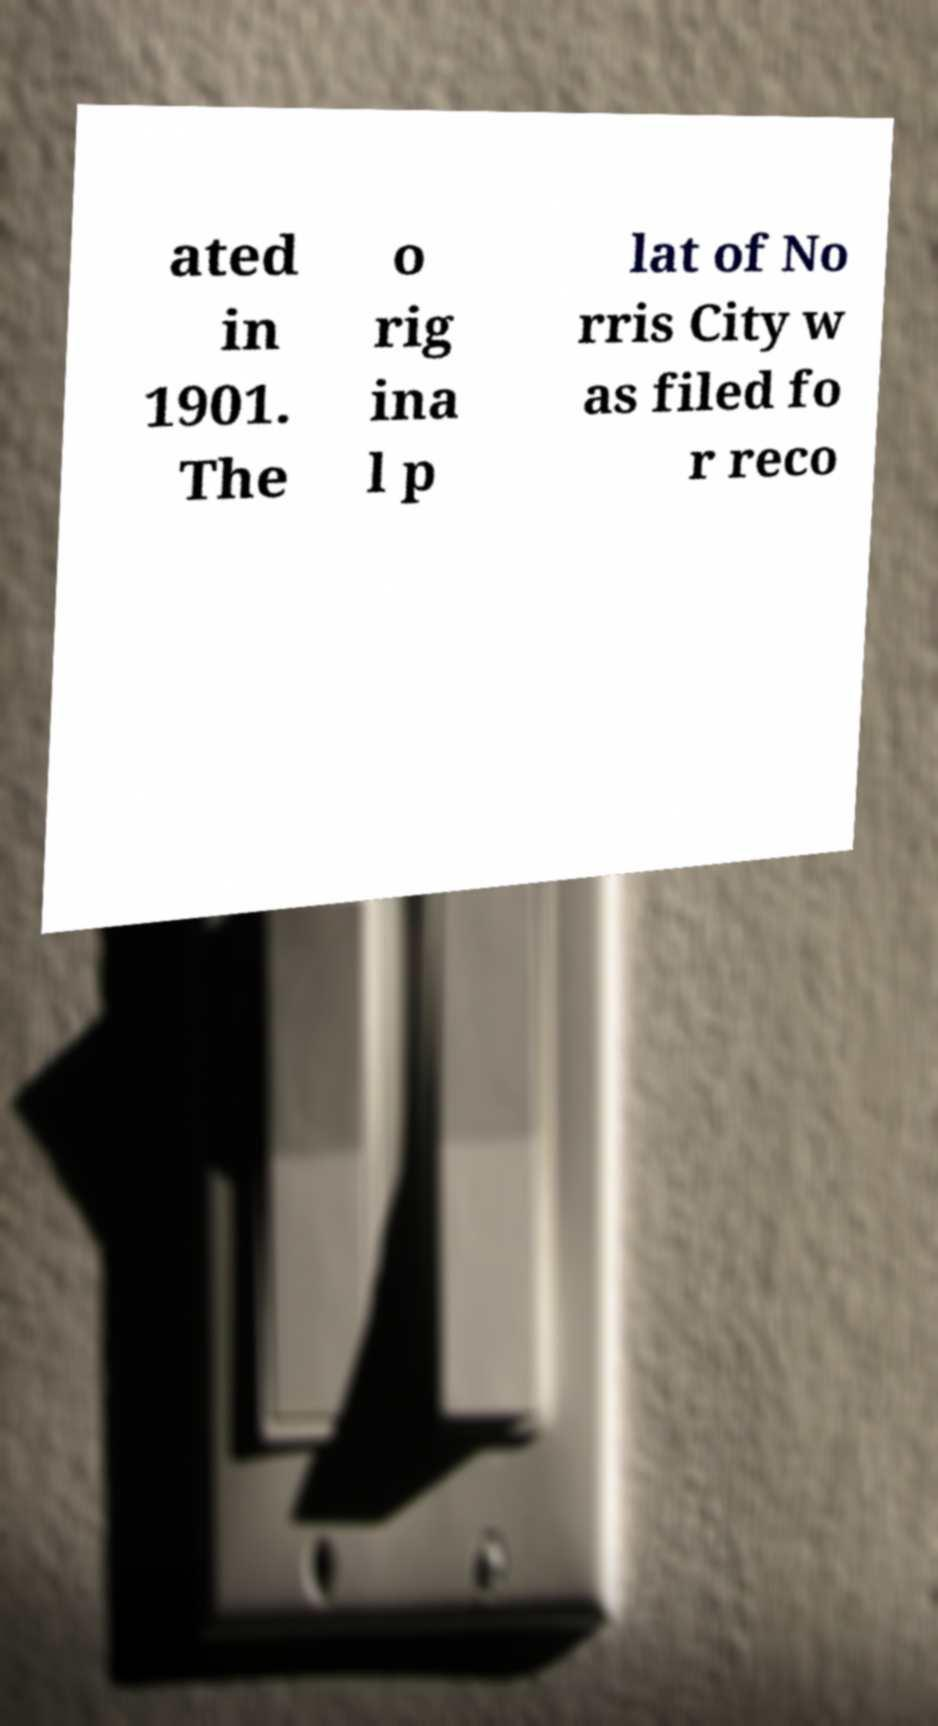There's text embedded in this image that I need extracted. Can you transcribe it verbatim? ated in 1901. The o rig ina l p lat of No rris City w as filed fo r reco 